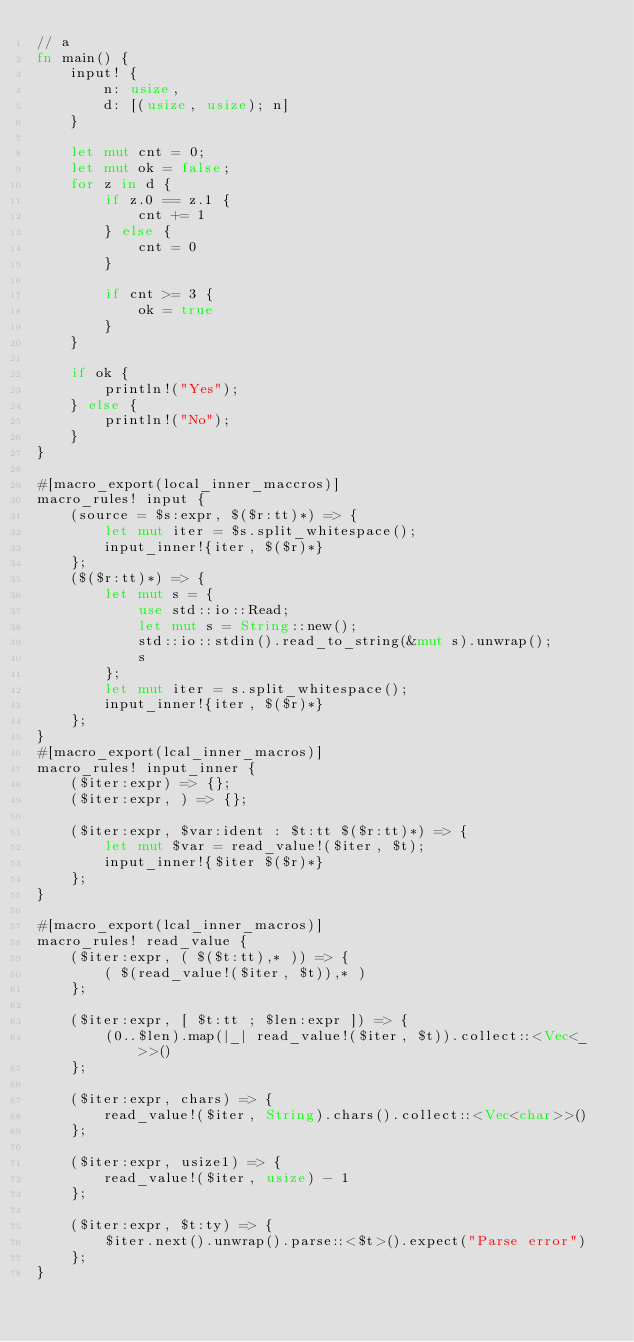<code> <loc_0><loc_0><loc_500><loc_500><_Rust_>// a
fn main() {
    input! {
        n: usize,
        d: [(usize, usize); n]
    }

    let mut cnt = 0;
    let mut ok = false;
    for z in d {
        if z.0 == z.1 {
            cnt += 1
        } else {
            cnt = 0
        }

        if cnt >= 3 {
            ok = true
        }
    }

    if ok {
        println!("Yes");
    } else {
        println!("No");
    }
}

#[macro_export(local_inner_maccros)]
macro_rules! input {
    (source = $s:expr, $($r:tt)*) => {
        let mut iter = $s.split_whitespace();
        input_inner!{iter, $($r)*}
    };
    ($($r:tt)*) => {
        let mut s = {
            use std::io::Read;
            let mut s = String::new();
            std::io::stdin().read_to_string(&mut s).unwrap();
            s
        };
        let mut iter = s.split_whitespace();
        input_inner!{iter, $($r)*}
    };
}
#[macro_export(lcal_inner_macros)]
macro_rules! input_inner {
    ($iter:expr) => {};
    ($iter:expr, ) => {};

    ($iter:expr, $var:ident : $t:tt $($r:tt)*) => {
        let mut $var = read_value!($iter, $t);
        input_inner!{$iter $($r)*}
    };
}

#[macro_export(lcal_inner_macros)]
macro_rules! read_value {
    ($iter:expr, ( $($t:tt),* )) => {
        ( $(read_value!($iter, $t)),* )
    };

    ($iter:expr, [ $t:tt ; $len:expr ]) => {
        (0..$len).map(|_| read_value!($iter, $t)).collect::<Vec<_>>()
    };

    ($iter:expr, chars) => {
        read_value!($iter, String).chars().collect::<Vec<char>>()
    };

    ($iter:expr, usize1) => {
        read_value!($iter, usize) - 1
    };

    ($iter:expr, $t:ty) => {
        $iter.next().unwrap().parse::<$t>().expect("Parse error")
    };
}
</code> 